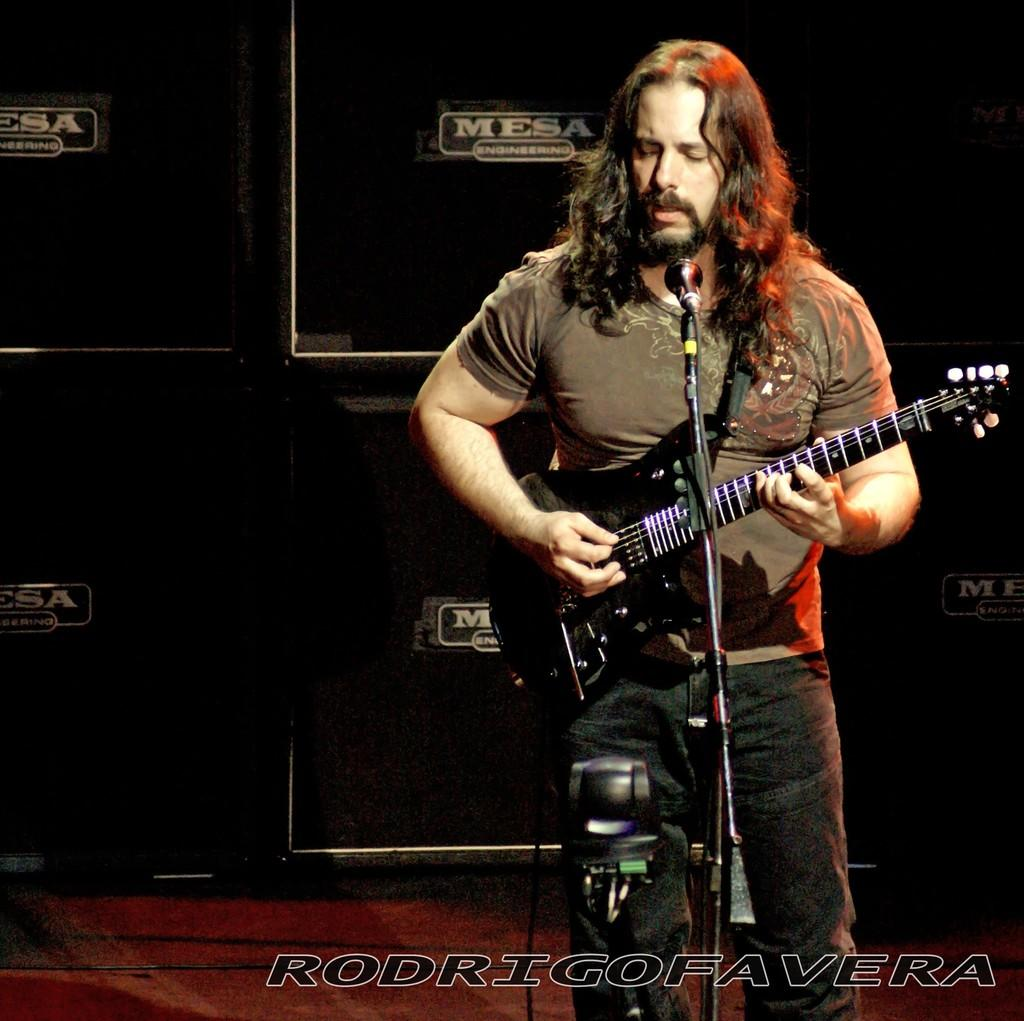What is the person in the image doing? The person is playing the guitar. What object is the person holding while playing the guitar? The person is holding a guitar. What device is in front of the person? There is a microphone in front of the person. What might the person be doing with the microphone? The person is likely singing through the microphone. How many dogs are running around the person in the image? There are no dogs present in the image. What is the person attempting to do with the guitar in the image? The person is not attempting to do anything with the guitar; they are already playing it. 